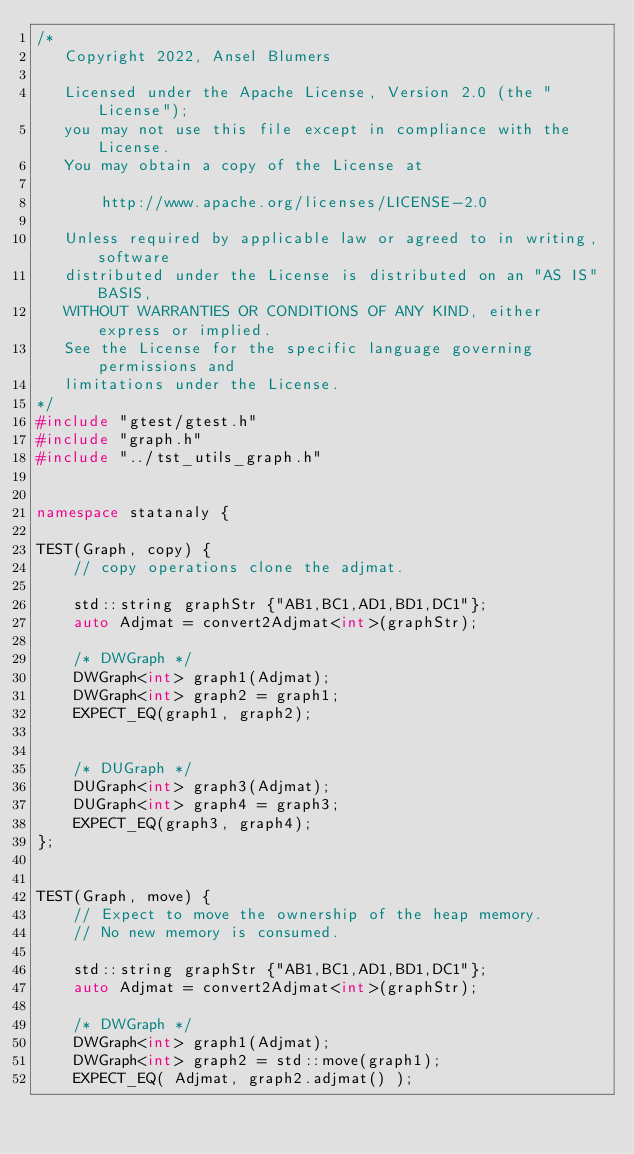Convert code to text. <code><loc_0><loc_0><loc_500><loc_500><_C++_>/*
   Copyright 2022, Ansel Blumers

   Licensed under the Apache License, Version 2.0 (the "License");
   you may not use this file except in compliance with the License.
   You may obtain a copy of the License at

       http://www.apache.org/licenses/LICENSE-2.0

   Unless required by applicable law or agreed to in writing, software
   distributed under the License is distributed on an "AS IS" BASIS,
   WITHOUT WARRANTIES OR CONDITIONS OF ANY KIND, either express or implied.
   See the License for the specific language governing permissions and
   limitations under the License.
*/
#include "gtest/gtest.h"
#include "graph.h"
#include "../tst_utils_graph.h"


namespace statanaly {

TEST(Graph, copy) {
    // copy operations clone the adjmat.

    std::string graphStr {"AB1,BC1,AD1,BD1,DC1"}; 
    auto Adjmat = convert2Adjmat<int>(graphStr);    

    /* DWGraph */
    DWGraph<int> graph1(Adjmat);
    DWGraph<int> graph2 = graph1;
    EXPECT_EQ(graph1, graph2);


    /* DUGraph */
    DUGraph<int> graph3(Adjmat);
    DUGraph<int> graph4 = graph3;
    EXPECT_EQ(graph3, graph4);
};


TEST(Graph, move) {
    // Expect to move the ownership of the heap memory.
    // No new memory is consumed.

    std::string graphStr {"AB1,BC1,AD1,BD1,DC1"}; 
    auto Adjmat = convert2Adjmat<int>(graphStr);    

    /* DWGraph */
    DWGraph<int> graph1(Adjmat);
    DWGraph<int> graph2 = std::move(graph1);
    EXPECT_EQ( Adjmat, graph2.adjmat() );</code> 